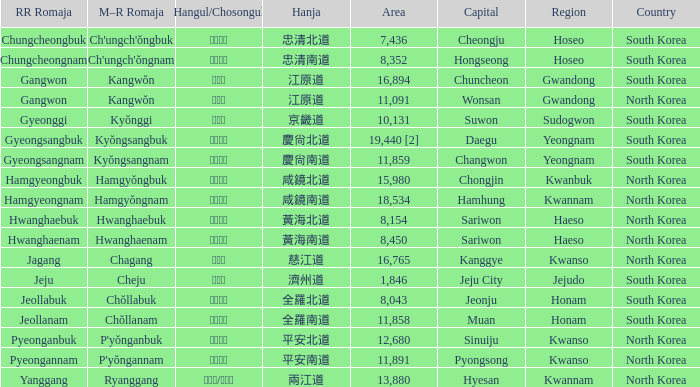What is the M-R Romaja for the province having a capital of Cheongju? Ch'ungch'ŏngbuk. 